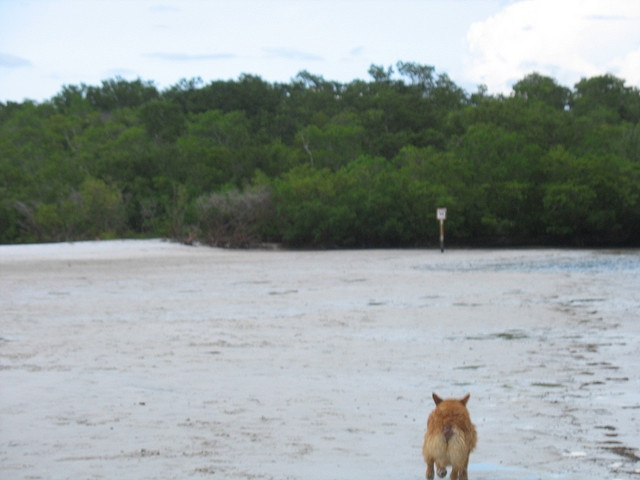Describe the objects in this image and their specific colors. I can see a dog in lightblue, gray, tan, and brown tones in this image. 